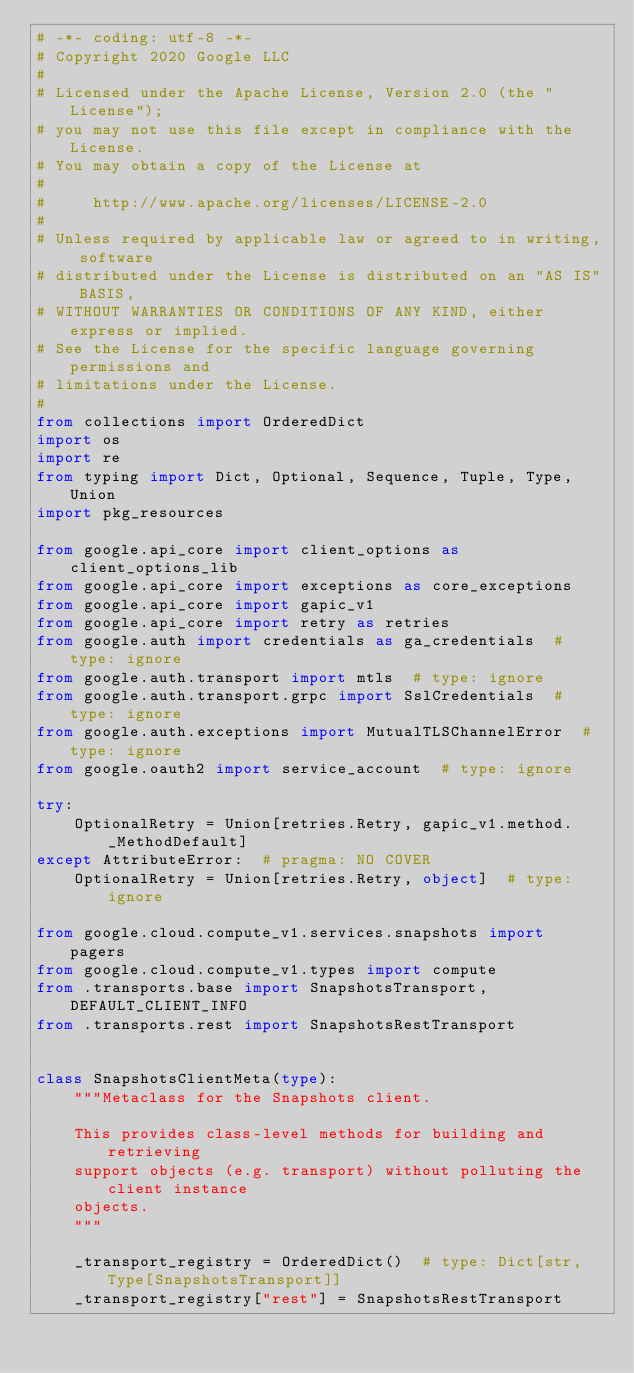Convert code to text. <code><loc_0><loc_0><loc_500><loc_500><_Python_># -*- coding: utf-8 -*-
# Copyright 2020 Google LLC
#
# Licensed under the Apache License, Version 2.0 (the "License");
# you may not use this file except in compliance with the License.
# You may obtain a copy of the License at
#
#     http://www.apache.org/licenses/LICENSE-2.0
#
# Unless required by applicable law or agreed to in writing, software
# distributed under the License is distributed on an "AS IS" BASIS,
# WITHOUT WARRANTIES OR CONDITIONS OF ANY KIND, either express or implied.
# See the License for the specific language governing permissions and
# limitations under the License.
#
from collections import OrderedDict
import os
import re
from typing import Dict, Optional, Sequence, Tuple, Type, Union
import pkg_resources

from google.api_core import client_options as client_options_lib
from google.api_core import exceptions as core_exceptions
from google.api_core import gapic_v1
from google.api_core import retry as retries
from google.auth import credentials as ga_credentials  # type: ignore
from google.auth.transport import mtls  # type: ignore
from google.auth.transport.grpc import SslCredentials  # type: ignore
from google.auth.exceptions import MutualTLSChannelError  # type: ignore
from google.oauth2 import service_account  # type: ignore

try:
    OptionalRetry = Union[retries.Retry, gapic_v1.method._MethodDefault]
except AttributeError:  # pragma: NO COVER
    OptionalRetry = Union[retries.Retry, object]  # type: ignore

from google.cloud.compute_v1.services.snapshots import pagers
from google.cloud.compute_v1.types import compute
from .transports.base import SnapshotsTransport, DEFAULT_CLIENT_INFO
from .transports.rest import SnapshotsRestTransport


class SnapshotsClientMeta(type):
    """Metaclass for the Snapshots client.

    This provides class-level methods for building and retrieving
    support objects (e.g. transport) without polluting the client instance
    objects.
    """

    _transport_registry = OrderedDict()  # type: Dict[str, Type[SnapshotsTransport]]
    _transport_registry["rest"] = SnapshotsRestTransport
</code> 